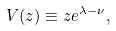Convert formula to latex. <formula><loc_0><loc_0><loc_500><loc_500>V ( z ) \equiv z e ^ { \lambda - \nu } ,</formula> 